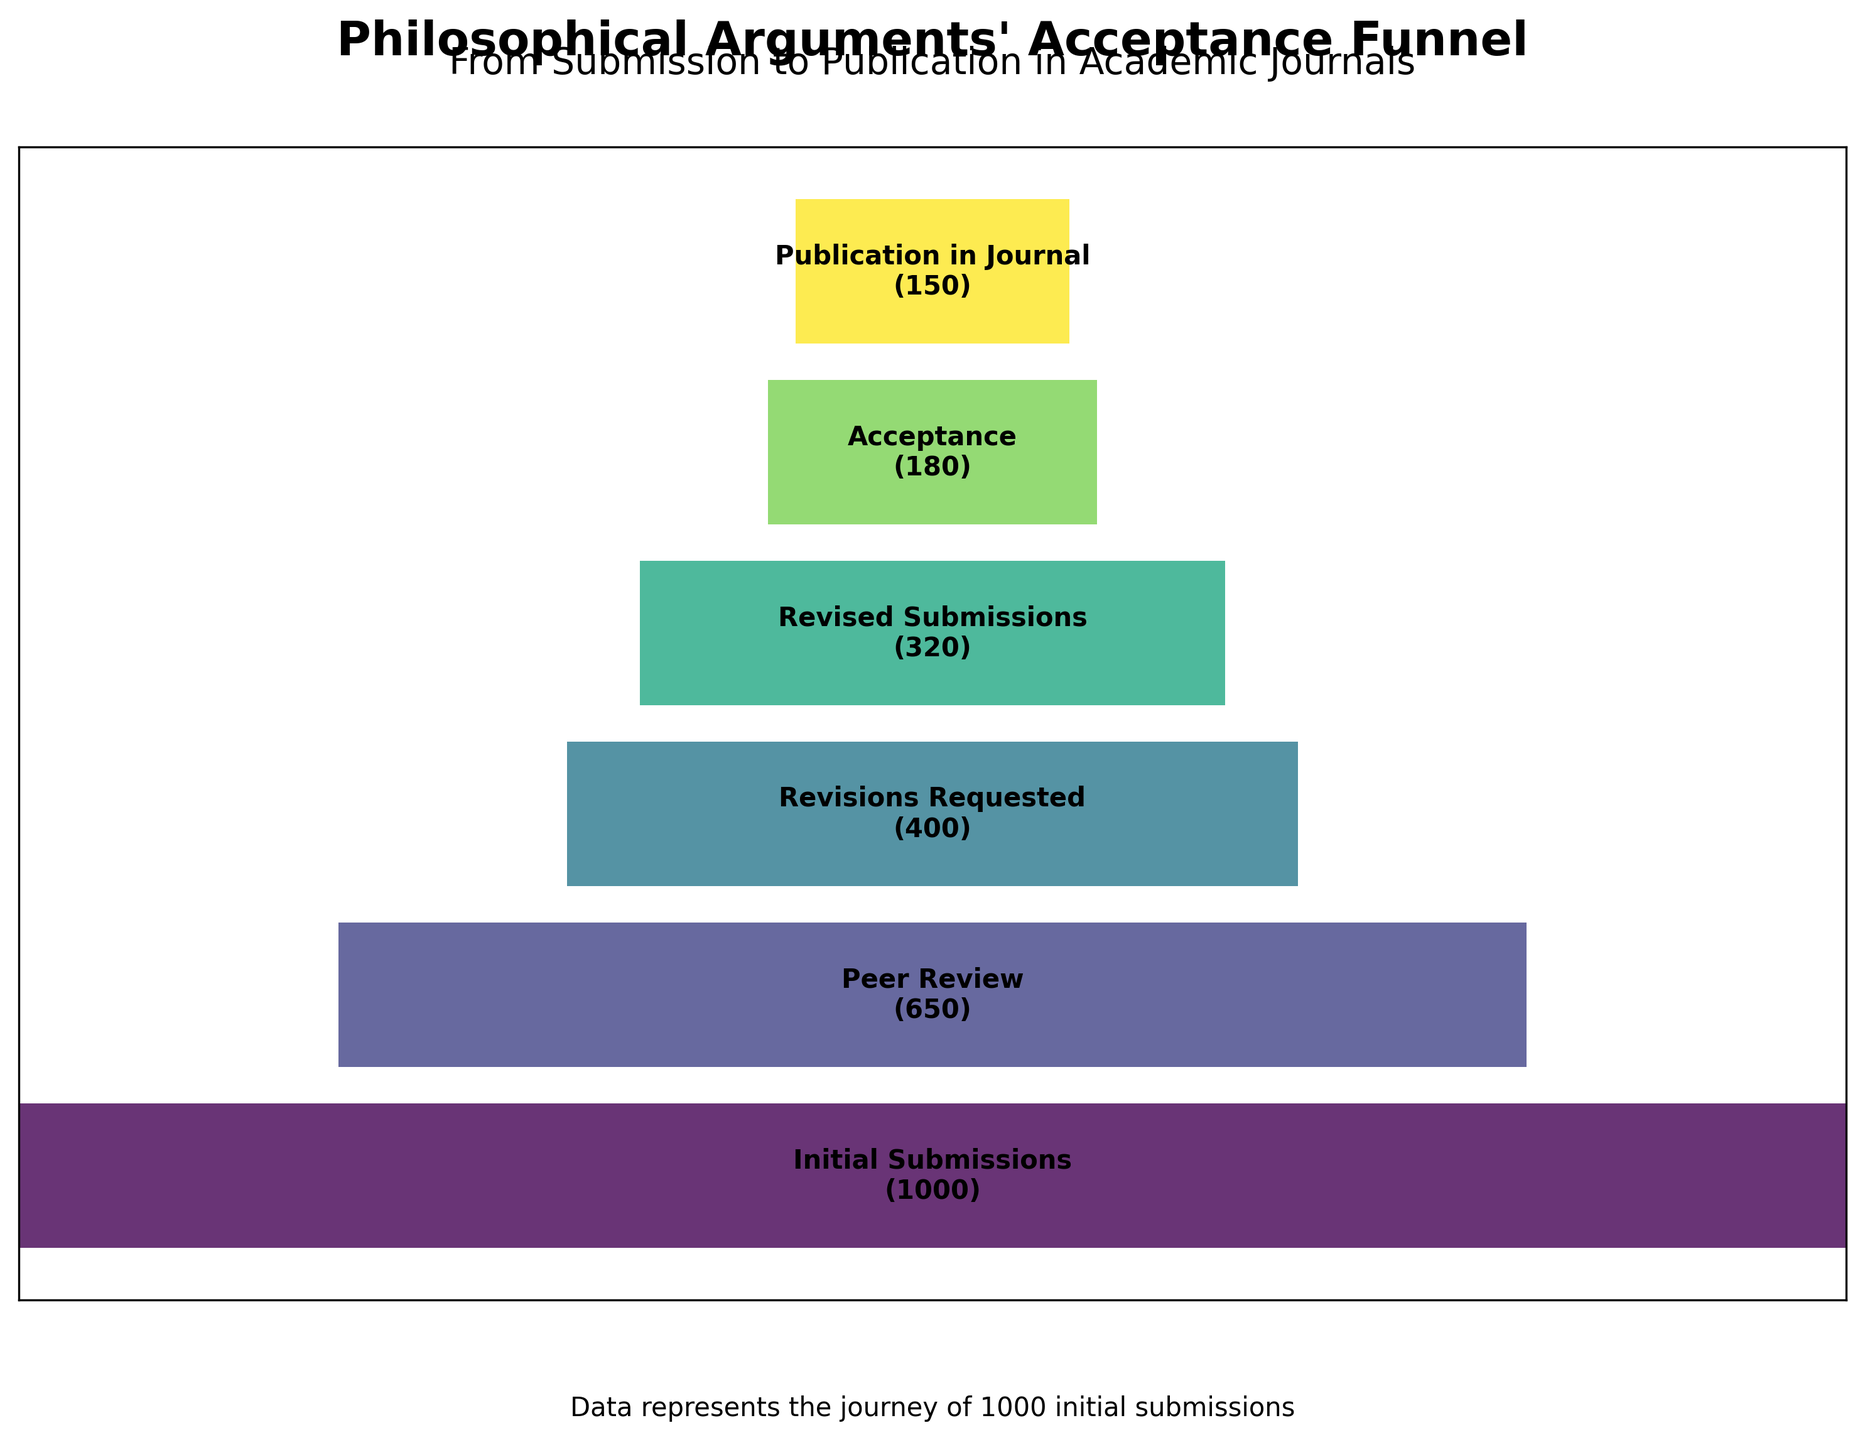What is the title of the chart? The chart's title is located at the top and provides a summary of the figure in a concise format. The title of the chart is "Philosophical Arguments' Acceptance Funnel".
Answer: Philosophical Arguments' Acceptance Funnel How many papers were initially submitted? The number of initially submitted papers is indicated at the top-most stage of the funnel. The label shows "Initial Submissions (1000)".
Answer: 1000 What is the final number of published papers? The final stage of the funnel indicates the number of papers that were published in the journal. The label shows "Publication in Journal (150)".
Answer: 150 How many papers were reviewed after the initial submission? The second stage of the funnel, labeled "Peer Review", shows how many papers progressed to peer review after the initial submissions. The label shows "Peer Review (650)".
Answer: 650 What is the difference between the number of revised submissions and initial submissions? To find the difference, subtract the number of revised submissions from the initial submissions. This is 1000 (Initial Submissions) - 320 (Revised Submissions).
Answer: 680 Which stage shows the highest drop in the number of papers? The biggest drop occurs between the stages with the largest numerical difference in papers. Evaluate the differences: Initial Submissions to Peer Review (1000-650=350), Peer Review to Revisions Requested (650-400=250), Revisions Requested to Revised Submissions (400-320=80), Revised Submissions to Acceptance (320-180=140), Acceptance to Publication in Journal (180-150=30). The largest drop is from the Initial Submissions to Peer Review.
Answer: Initial Submissions to Peer Review What percentage of the initial submissions were eventually published in the journal? To calculate the percentage, divide the number of published papers by the number of initial submissions and multiply by 100: (150 / 1000) * 100.
Answer: 15% How many papers were requested for revision but did not submit a revision? Subtract the number of revised submissions from the number of revisions requested: 400 (Revisions Requested) - 320 (Revised Submissions).
Answer: 80 Which stage had the smallest reduction in the number of papers? Identify the stages with the smallest numerical difference: Initial Submissions to Peer Review (350), Peer Review to Revisions Requested (250), Revisions Requested to Revised Submissions (80), Revised Submissions to Acceptance (140), Acceptance to Publication in Journal (30). The smallest reduction is from Acceptance to Publication in Journal.
Answer: Acceptance to Publication in Journal How do the changes in numbers across stages reflect the evaluation process of academic journals? Each stage reflects a strict evaluation process, from initial submission to final publication. The significant drop from initial submissions to peer review shows that many papers do not pass preliminary checks. Further stages show fewer but still substantial drops, indicating rigorous scrutiny and revision requirements. Finally, not all accepted papers are published, reflecting final checks and editorial decisions.
Answer: Rigorous evaluation at each stage 